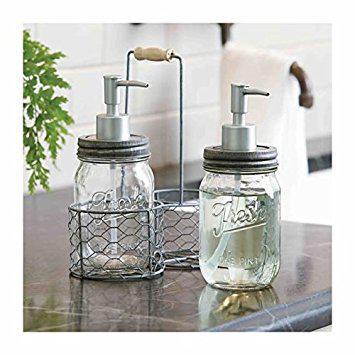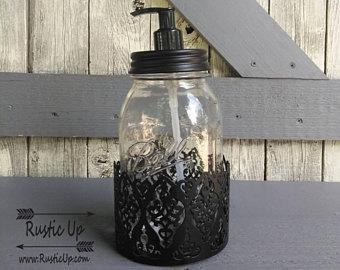The first image is the image on the left, the second image is the image on the right. Evaluate the accuracy of this statement regarding the images: "At least one bottle dispenser is facing left.". Is it true? Answer yes or no. Yes. The first image is the image on the left, the second image is the image on the right. Assess this claim about the two images: "Each image shows a carrier holding two pump-top jars.". Correct or not? Answer yes or no. No. 